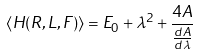Convert formula to latex. <formula><loc_0><loc_0><loc_500><loc_500>\langle H ( R , L , F ) \rangle = E _ { 0 } + \lambda ^ { 2 } + \frac { 4 A } { \frac { d A } { d \lambda } }</formula> 